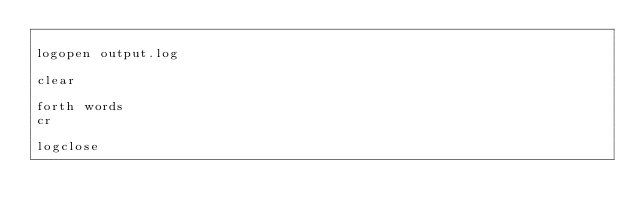<code> <loc_0><loc_0><loc_500><loc_500><_Forth_>
logopen output.log

clear

forth words
cr

logclose
</code> 